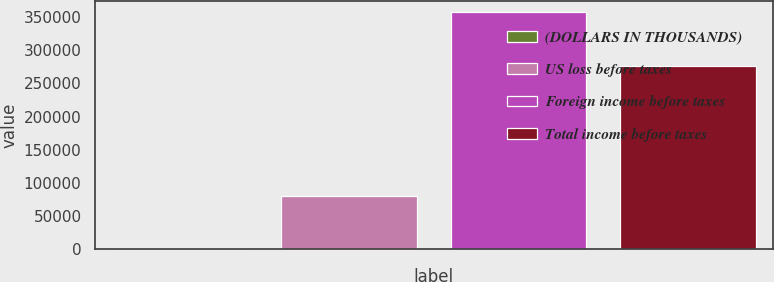Convert chart to OTSL. <chart><loc_0><loc_0><loc_500><loc_500><bar_chart><fcel>(DOLLARS IN THOUSANDS)<fcel>US loss before taxes<fcel>Foreign income before taxes<fcel>Total income before taxes<nl><fcel>2009<fcel>80345<fcel>356894<fcel>276549<nl></chart> 